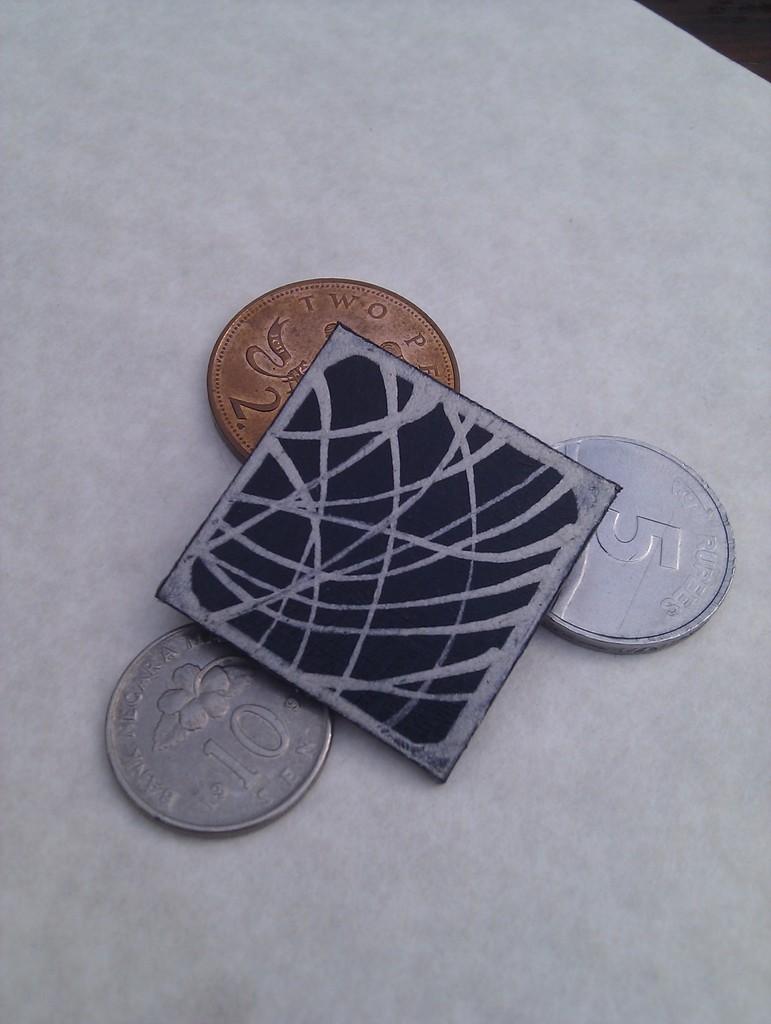What number is on the bronze coin?
Your response must be concise. 2. What is the value of the silver coin on bottom?
Provide a short and direct response. 10. 